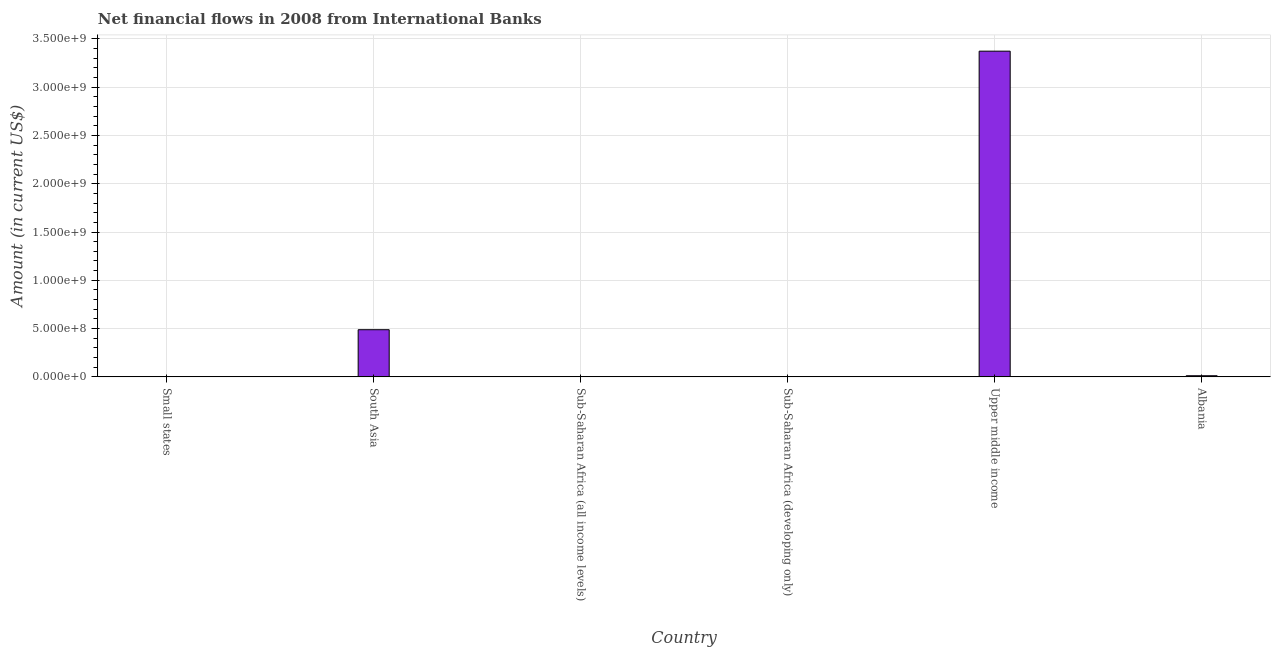Does the graph contain any zero values?
Give a very brief answer. Yes. What is the title of the graph?
Your response must be concise. Net financial flows in 2008 from International Banks. What is the label or title of the Y-axis?
Keep it short and to the point. Amount (in current US$). What is the net financial flows from ibrd in South Asia?
Provide a succinct answer. 4.88e+08. Across all countries, what is the maximum net financial flows from ibrd?
Your answer should be compact. 3.37e+09. In which country was the net financial flows from ibrd maximum?
Make the answer very short. Upper middle income. What is the sum of the net financial flows from ibrd?
Your answer should be very brief. 3.87e+09. What is the difference between the net financial flows from ibrd in Albania and Upper middle income?
Ensure brevity in your answer.  -3.36e+09. What is the average net financial flows from ibrd per country?
Keep it short and to the point. 6.45e+08. What is the median net financial flows from ibrd?
Give a very brief answer. 5.87e+06. In how many countries, is the net financial flows from ibrd greater than 2200000000 US$?
Your response must be concise. 1. What is the ratio of the net financial flows from ibrd in Albania to that in Upper middle income?
Offer a very short reply. 0. What is the difference between the highest and the second highest net financial flows from ibrd?
Your response must be concise. 2.88e+09. Is the sum of the net financial flows from ibrd in South Asia and Upper middle income greater than the maximum net financial flows from ibrd across all countries?
Provide a short and direct response. Yes. What is the difference between the highest and the lowest net financial flows from ibrd?
Your response must be concise. 3.37e+09. Are the values on the major ticks of Y-axis written in scientific E-notation?
Your response must be concise. Yes. What is the Amount (in current US$) of Small states?
Give a very brief answer. 0. What is the Amount (in current US$) of South Asia?
Provide a short and direct response. 4.88e+08. What is the Amount (in current US$) in Upper middle income?
Make the answer very short. 3.37e+09. What is the Amount (in current US$) in Albania?
Your answer should be very brief. 1.17e+07. What is the difference between the Amount (in current US$) in South Asia and Upper middle income?
Ensure brevity in your answer.  -2.88e+09. What is the difference between the Amount (in current US$) in South Asia and Albania?
Your response must be concise. 4.77e+08. What is the difference between the Amount (in current US$) in Upper middle income and Albania?
Your answer should be compact. 3.36e+09. What is the ratio of the Amount (in current US$) in South Asia to that in Upper middle income?
Your response must be concise. 0.14. What is the ratio of the Amount (in current US$) in South Asia to that in Albania?
Provide a short and direct response. 41.61. What is the ratio of the Amount (in current US$) in Upper middle income to that in Albania?
Provide a succinct answer. 287.38. 